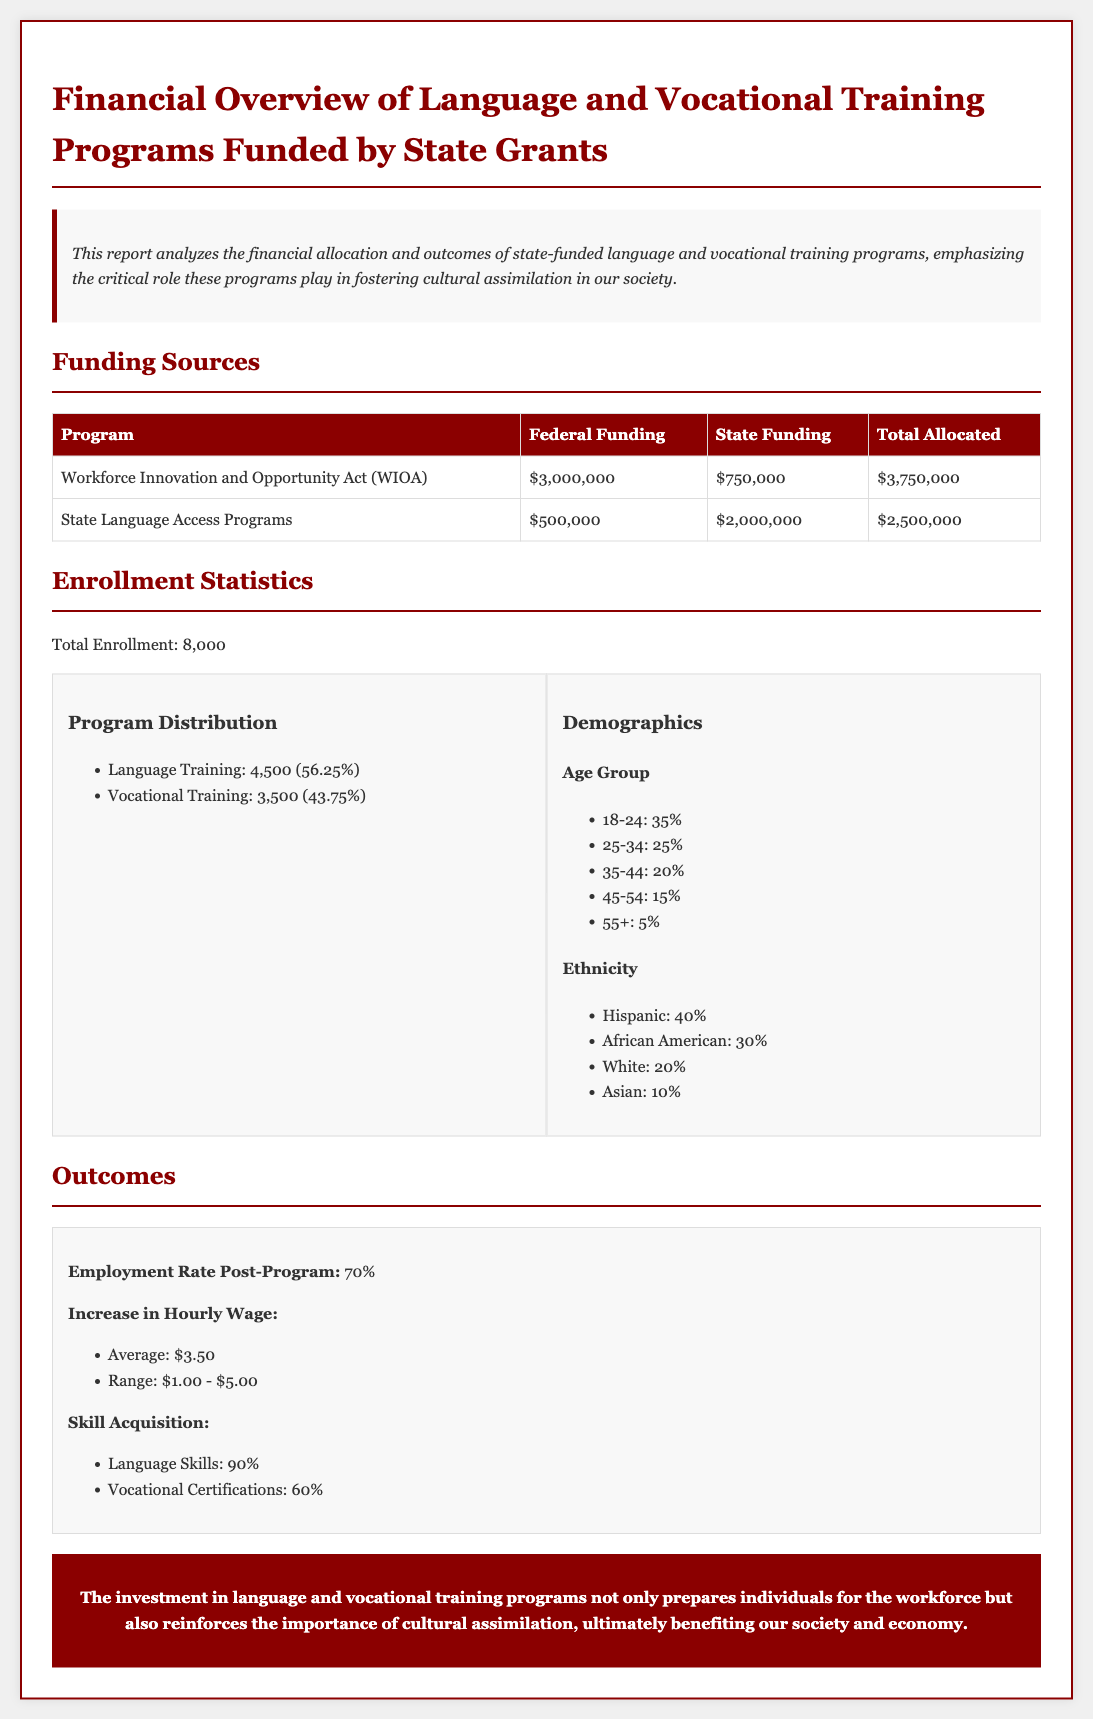What is the total federal funding for the WIOA program? The WIOA program has total federal funding of $3,000,000 as listed in the funding table.
Answer: $3,000,000 What percentage of total enrollment is in vocational training? Vocational training enrollment is 3,500 out of 8,000, which calculates to 43.75%.
Answer: 43.75% What is the employment rate post-program? The document states that the employment rate post-program is 70%.
Answer: 70% How much total funding is allocated for State Language Access Programs? The total allocated funding for State Language Access Programs is $2,500,000 as indicated in the funding table.
Answer: $2,500,000 What is the increase in the average hourly wage? According to the outcomes section, the average increase in hourly wage is $3.50.
Answer: $3.50 What is the demographic percentage for the 18-24 age group? The document indicates that 35% of the enrolled participants fall into the 18-24 age group.
Answer: 35% How many total individuals are enrolled in the programs? The total enrollment reported in the document is 8,000 individuals.
Answer: 8,000 What type of training had a higher enrollment number? The document shows that language training had a higher enrollment number at 4,500 compared to vocational training.
Answer: Language Training What is the rate of acquiring language skills post-program? The outcomes section states that 90% of participants acquired language skills after completing the program.
Answer: 90% 